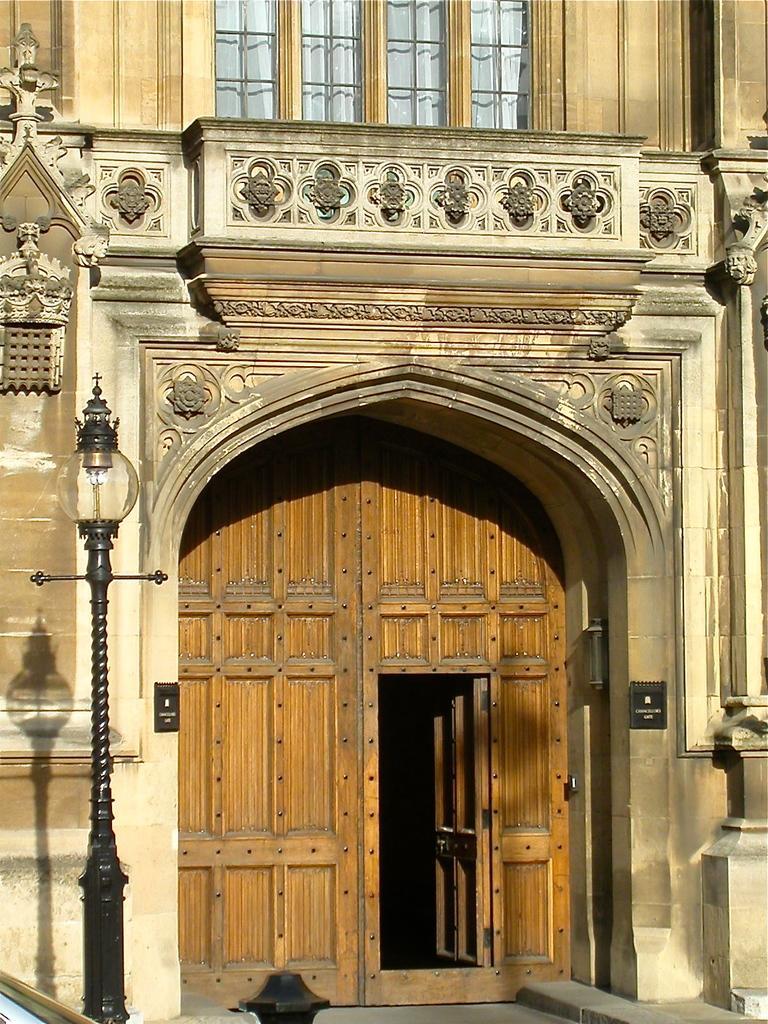Could you give a brief overview of what you see in this image? On the left side, there is a light attached to a pole. In the background, there is a building having wooden gate and a glass window. 